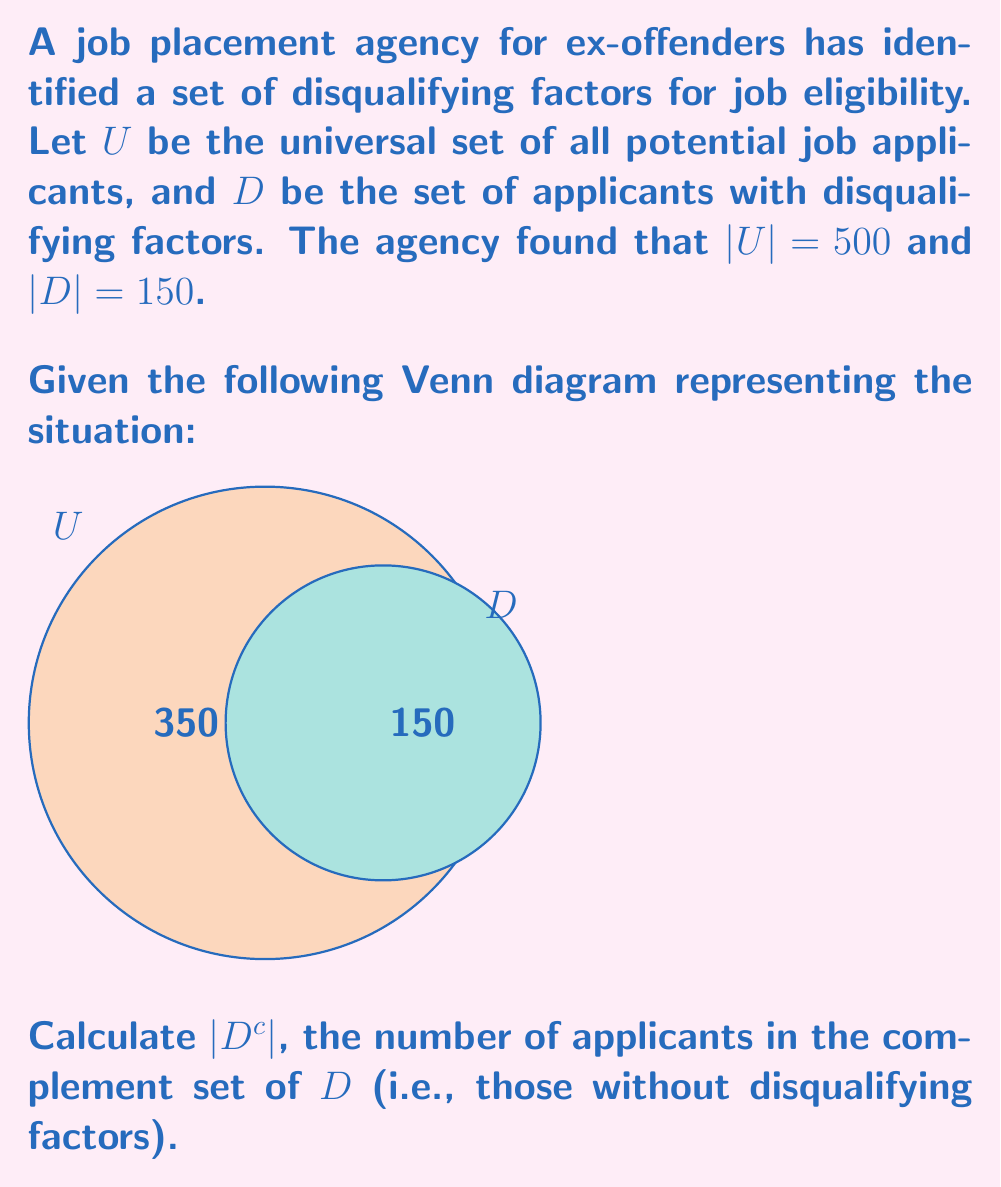Give your solution to this math problem. To solve this problem, let's follow these steps:

1) First, recall that the complement set $D^c$ consists of all elements in the universal set $U$ that are not in set $D$.

2) We can represent this relationship mathematically as:
   $$D^c = U \setminus D$$

3) The cardinality of the complement set can be calculated using the formula:
   $$|D^c| = |U| - |D|$$

4) We are given that:
   $|U| = 500$ (total number of potential applicants)
   $|D| = 150$ (number of applicants with disqualifying factors)

5) Substituting these values into our formula:
   $$|D^c| = 500 - 150$$

6) Calculating:
   $$|D^c| = 350$$

Therefore, there are 350 applicants in the complement set of $D$, meaning 350 applicants do not have disqualifying factors and are potentially eligible for job placement.
Answer: $|D^c| = 350$ 